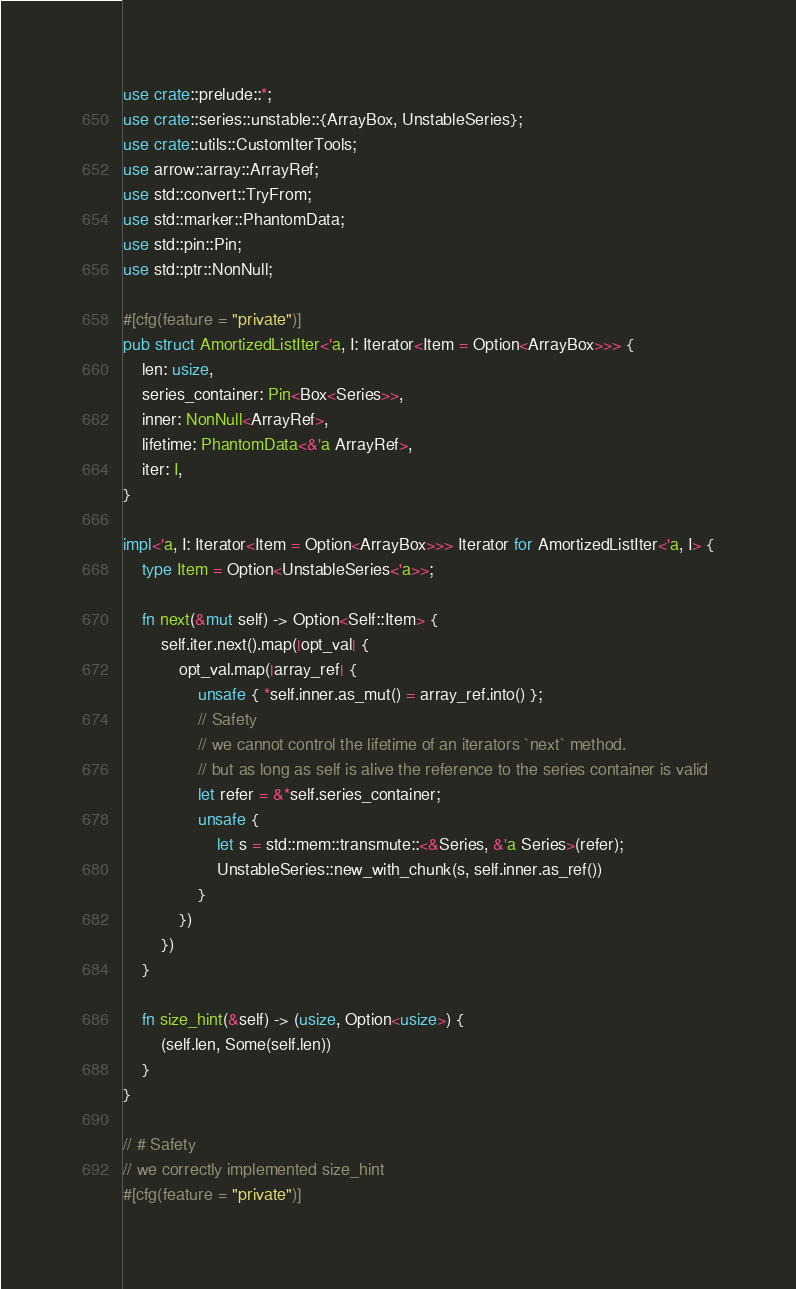Convert code to text. <code><loc_0><loc_0><loc_500><loc_500><_Rust_>use crate::prelude::*;
use crate::series::unstable::{ArrayBox, UnstableSeries};
use crate::utils::CustomIterTools;
use arrow::array::ArrayRef;
use std::convert::TryFrom;
use std::marker::PhantomData;
use std::pin::Pin;
use std::ptr::NonNull;

#[cfg(feature = "private")]
pub struct AmortizedListIter<'a, I: Iterator<Item = Option<ArrayBox>>> {
    len: usize,
    series_container: Pin<Box<Series>>,
    inner: NonNull<ArrayRef>,
    lifetime: PhantomData<&'a ArrayRef>,
    iter: I,
}

impl<'a, I: Iterator<Item = Option<ArrayBox>>> Iterator for AmortizedListIter<'a, I> {
    type Item = Option<UnstableSeries<'a>>;

    fn next(&mut self) -> Option<Self::Item> {
        self.iter.next().map(|opt_val| {
            opt_val.map(|array_ref| {
                unsafe { *self.inner.as_mut() = array_ref.into() };
                // Safety
                // we cannot control the lifetime of an iterators `next` method.
                // but as long as self is alive the reference to the series container is valid
                let refer = &*self.series_container;
                unsafe {
                    let s = std::mem::transmute::<&Series, &'a Series>(refer);
                    UnstableSeries::new_with_chunk(s, self.inner.as_ref())
                }
            })
        })
    }

    fn size_hint(&self) -> (usize, Option<usize>) {
        (self.len, Some(self.len))
    }
}

// # Safety
// we correctly implemented size_hint
#[cfg(feature = "private")]</code> 